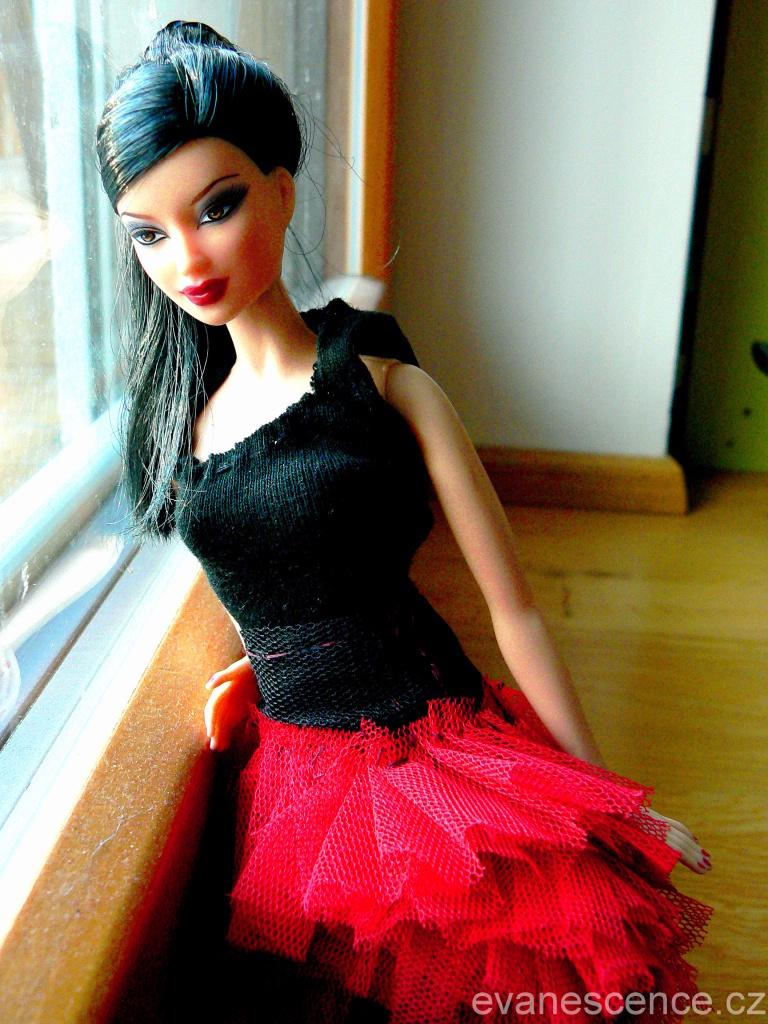What is placed on the floor in the image? There is a doll on the floor. What can be seen on the left side of the image? There is a glass on the left side of the image. What is visible in the background of the image? There is a wall in the background of the image. Where is the text located in the image? The text is on the bottom right of the image. What type of rings can be seen on the doll's fingers in the image? There are no rings visible on the doll's fingers in the image. What is the church doing in the image? There is no church present in the image. 